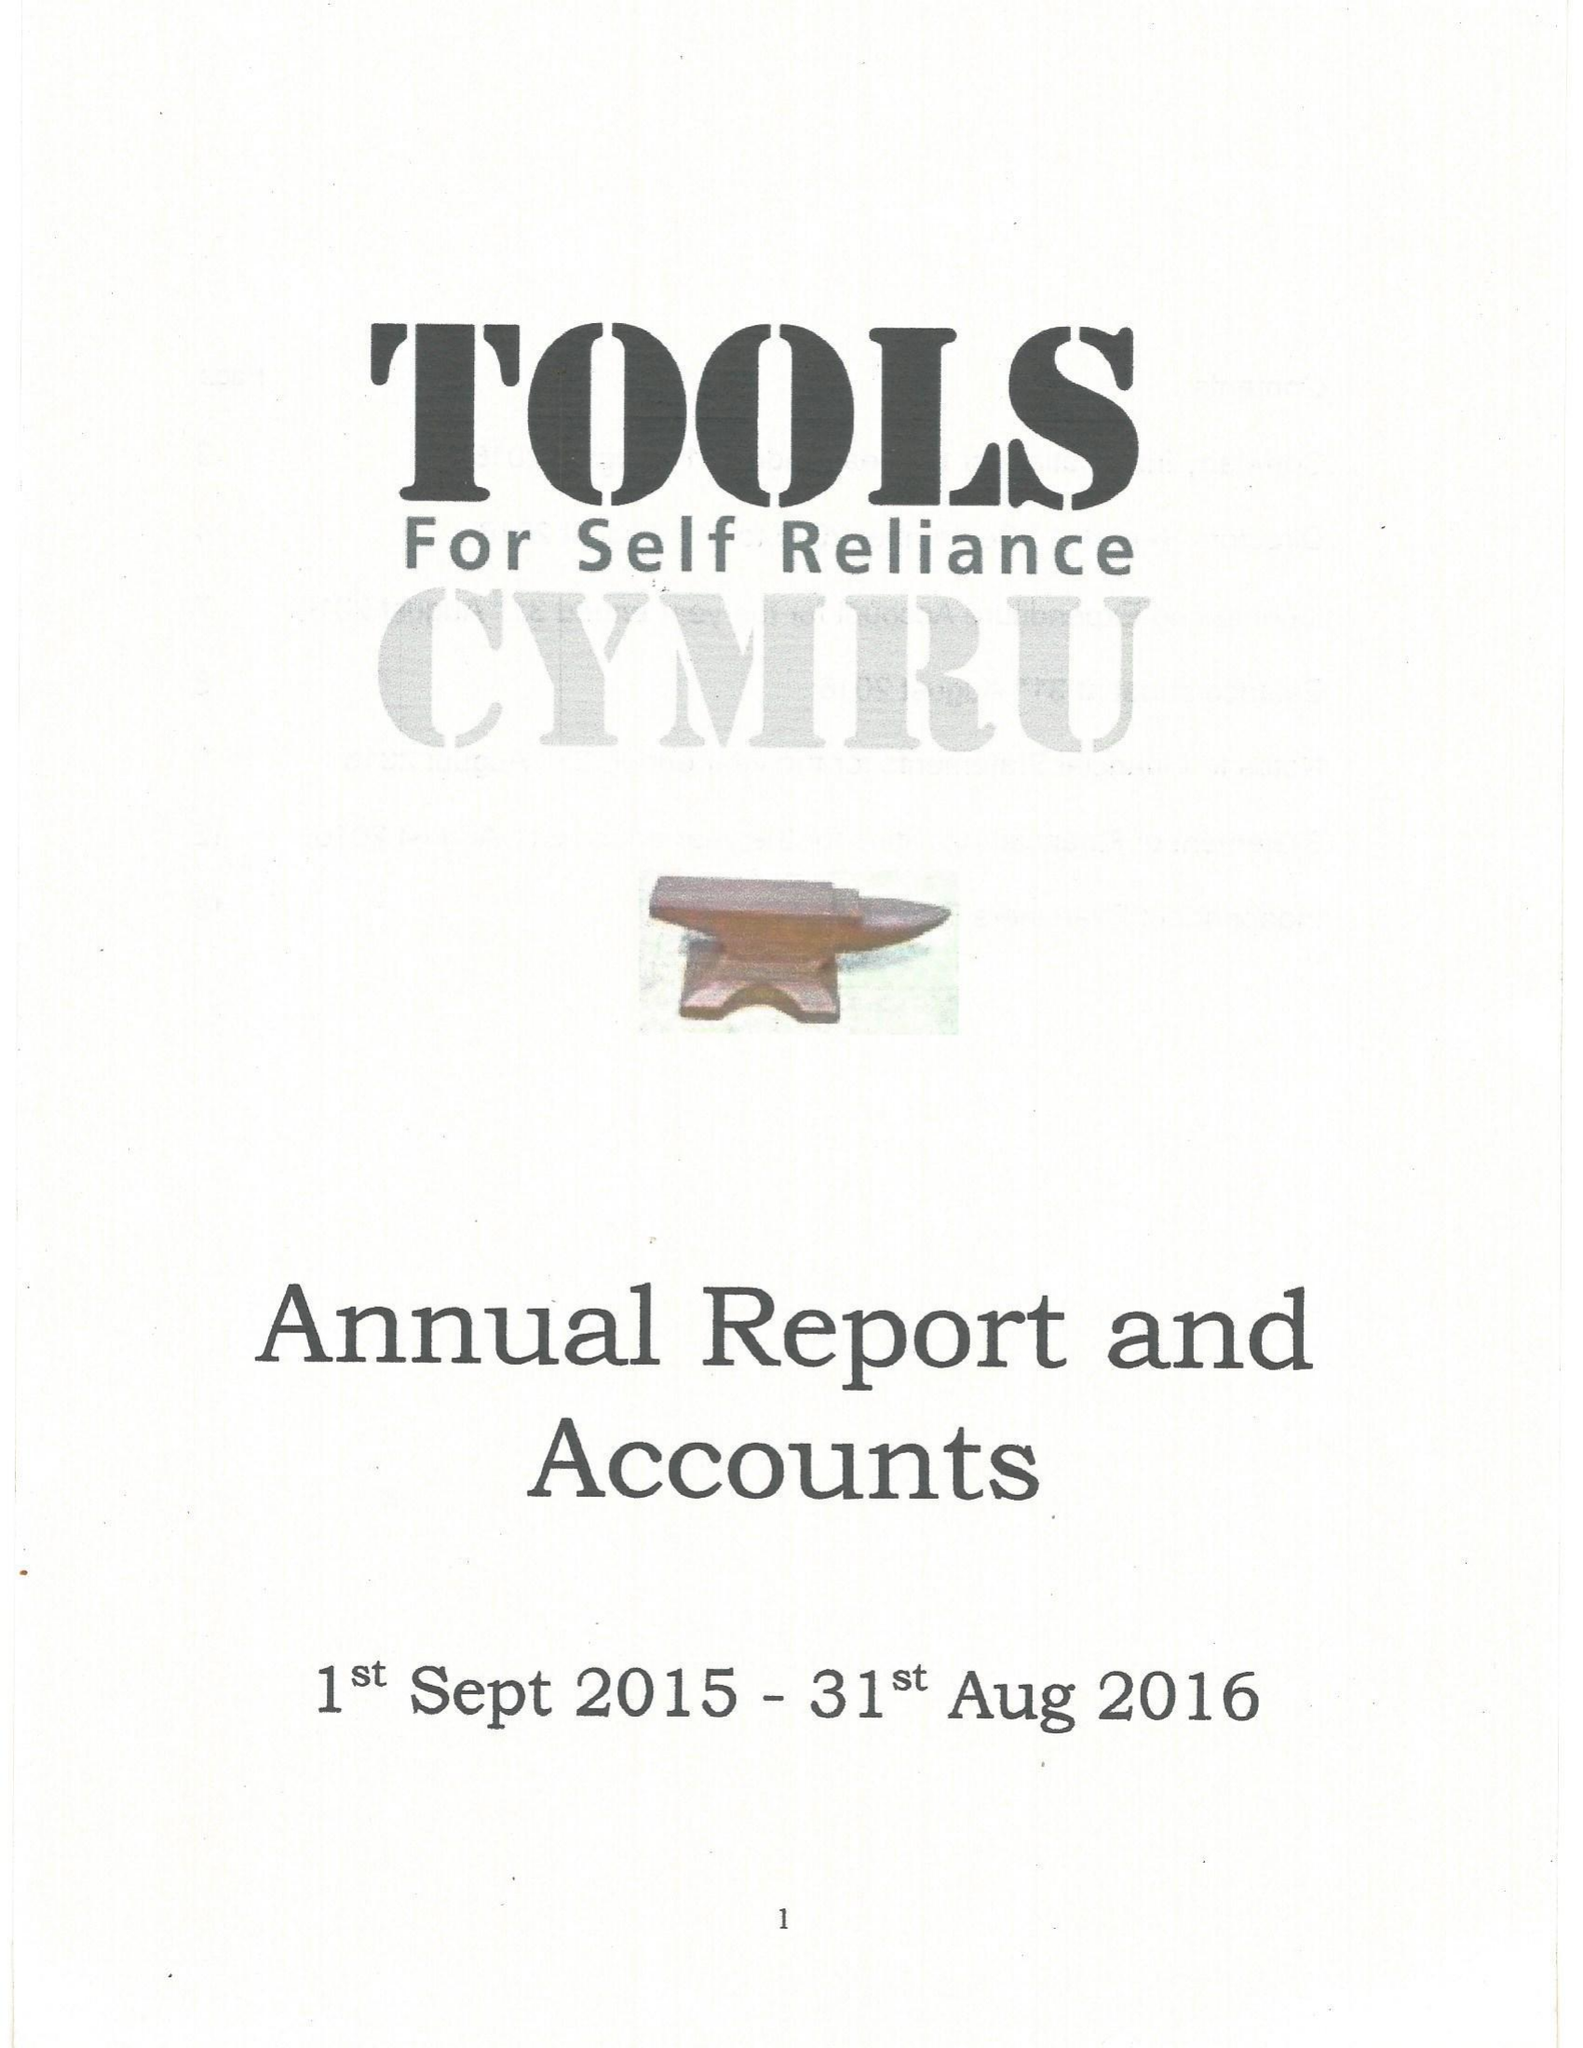What is the value for the charity_name?
Answer the question using a single word or phrase. Tools For Self Reliance Cymru Ltd. 